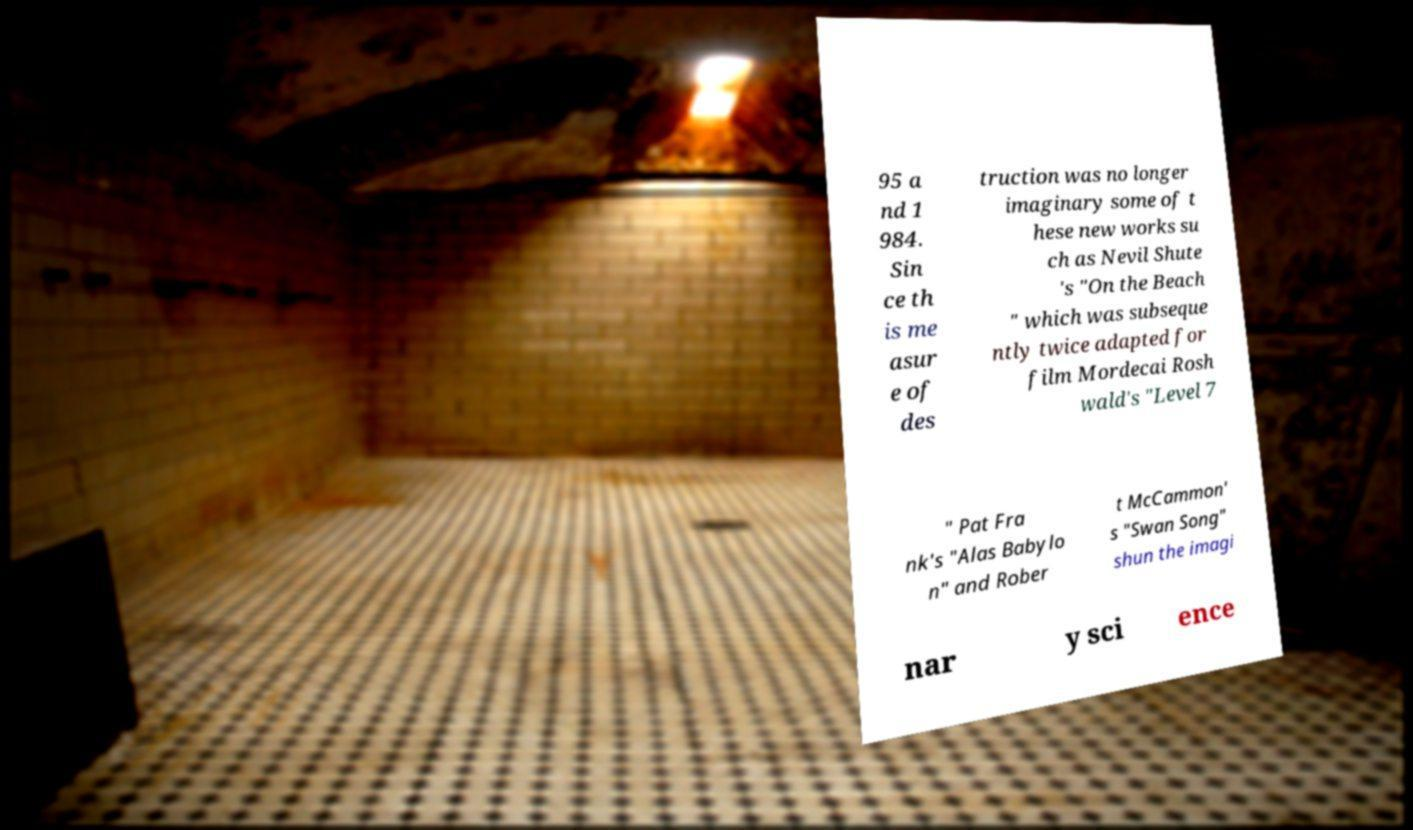For documentation purposes, I need the text within this image transcribed. Could you provide that? 95 a nd 1 984. Sin ce th is me asur e of des truction was no longer imaginary some of t hese new works su ch as Nevil Shute 's "On the Beach " which was subseque ntly twice adapted for film Mordecai Rosh wald's "Level 7 " Pat Fra nk's "Alas Babylo n" and Rober t McCammon' s "Swan Song" shun the imagi nar y sci ence 